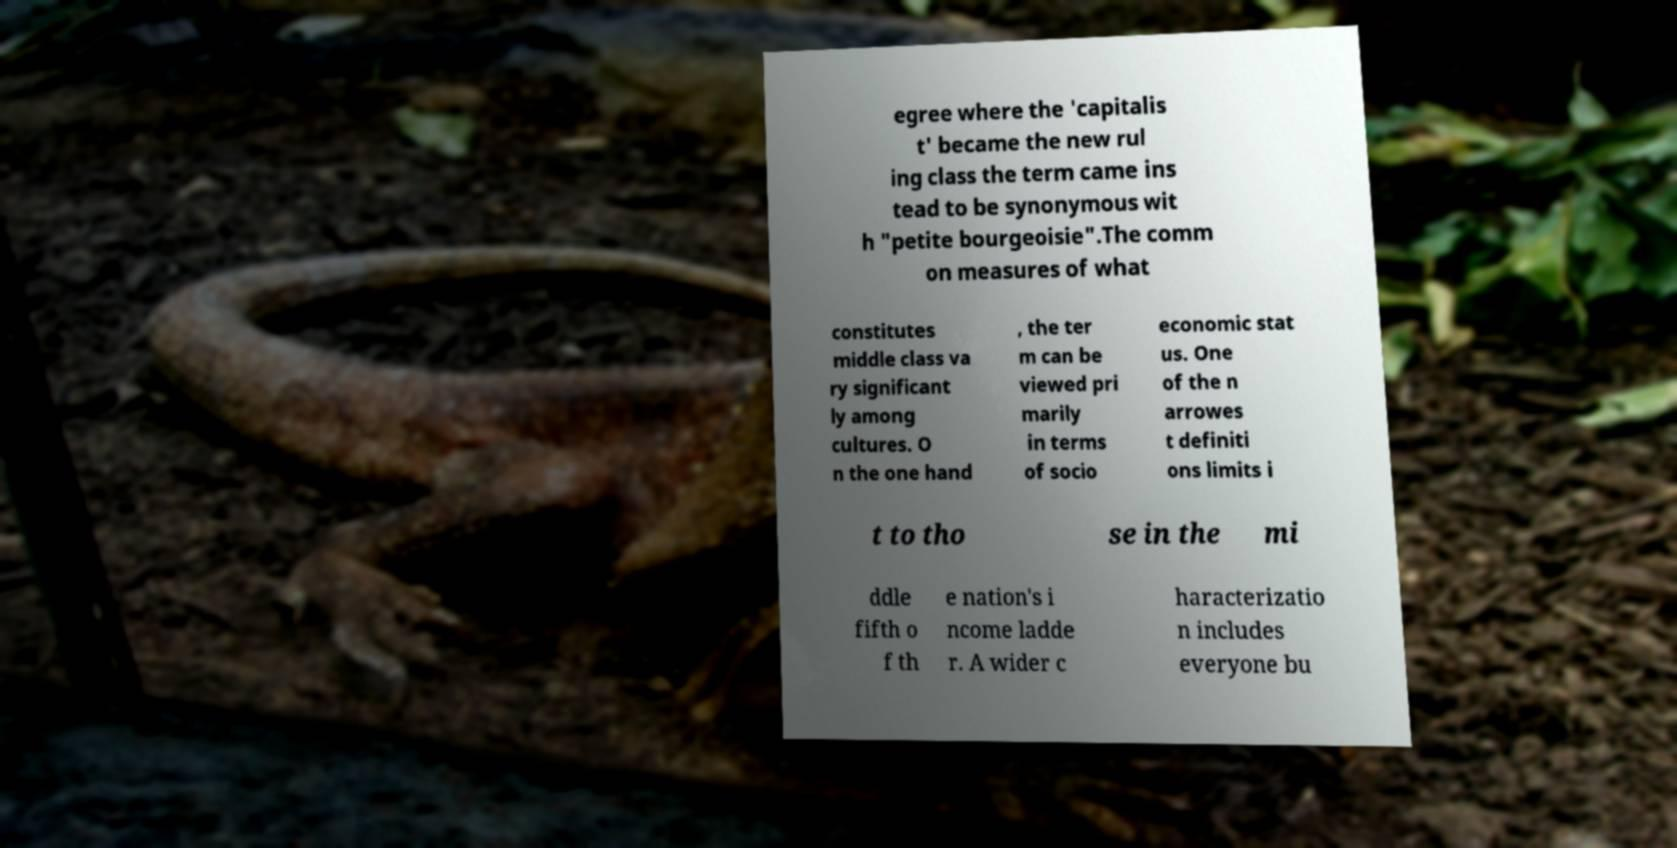Please identify and transcribe the text found in this image. egree where the 'capitalis t' became the new rul ing class the term came ins tead to be synonymous wit h "petite bourgeoisie".The comm on measures of what constitutes middle class va ry significant ly among cultures. O n the one hand , the ter m can be viewed pri marily in terms of socio economic stat us. One of the n arrowes t definiti ons limits i t to tho se in the mi ddle fifth o f th e nation's i ncome ladde r. A wider c haracterizatio n includes everyone bu 